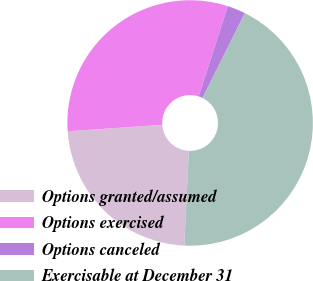Convert chart. <chart><loc_0><loc_0><loc_500><loc_500><pie_chart><fcel>Options granted/assumed<fcel>Options exercised<fcel>Options canceled<fcel>Exercisable at December 31<nl><fcel>23.17%<fcel>31.05%<fcel>2.39%<fcel>43.39%<nl></chart> 